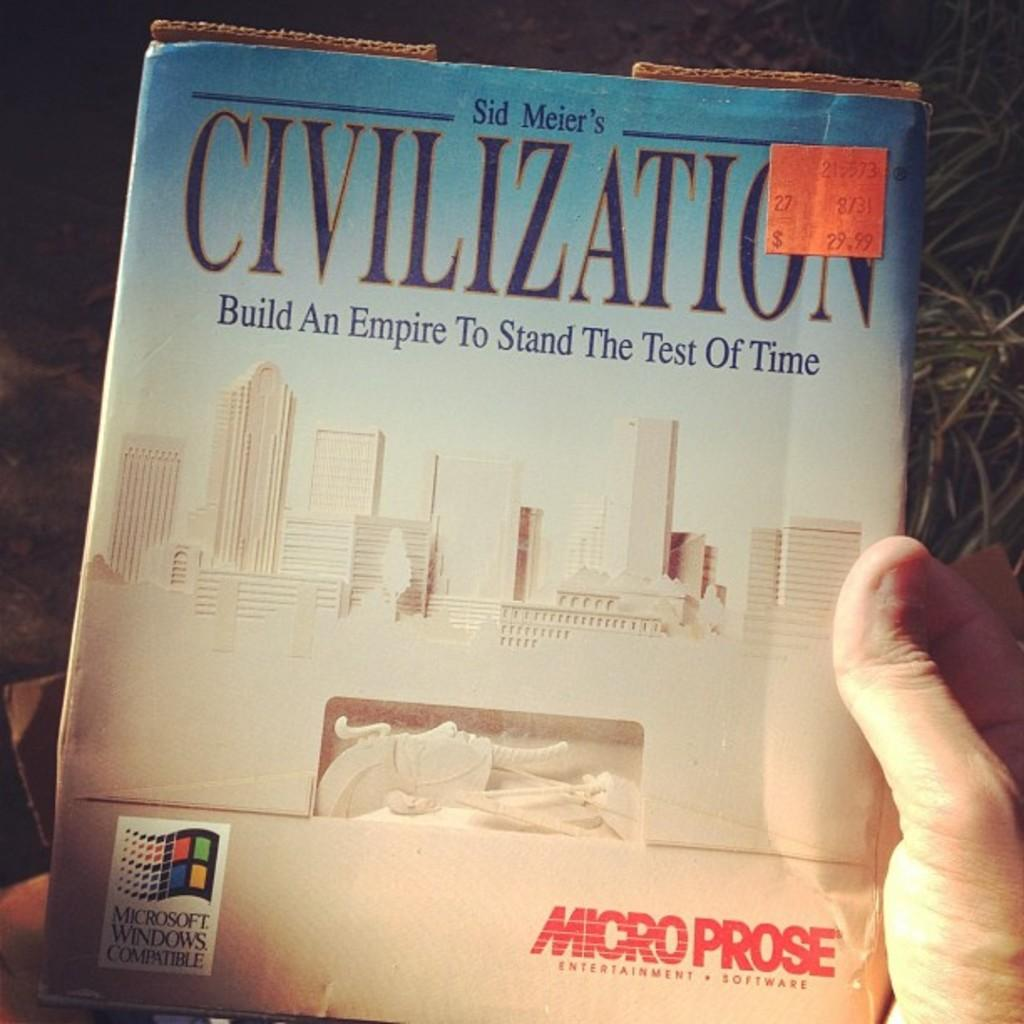<image>
Give a short and clear explanation of the subsequent image. Someone holds a book cover for Civilization by Sid Meier. 